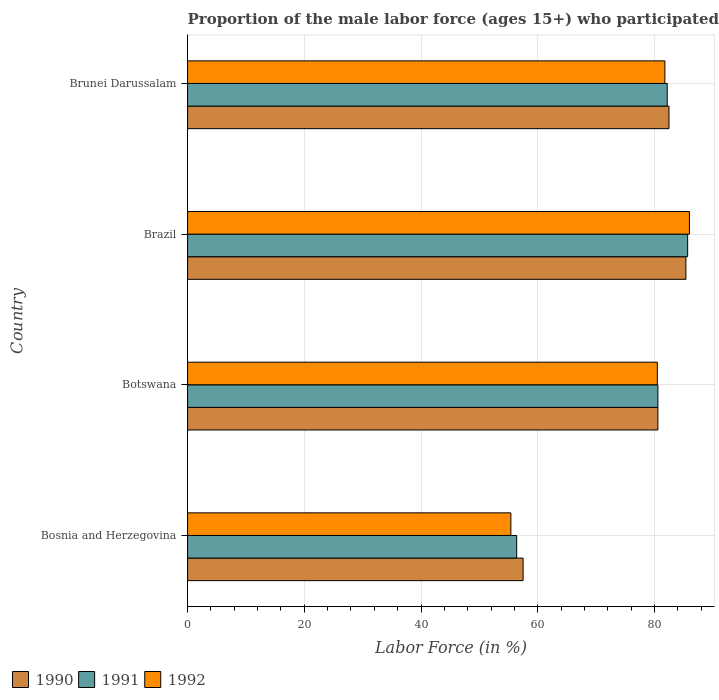How many different coloured bars are there?
Provide a short and direct response. 3. How many groups of bars are there?
Your response must be concise. 4. How many bars are there on the 3rd tick from the top?
Ensure brevity in your answer.  3. What is the label of the 1st group of bars from the top?
Keep it short and to the point. Brunei Darussalam. What is the proportion of the male labor force who participated in production in 1990 in Bosnia and Herzegovina?
Ensure brevity in your answer.  57.5. Across all countries, what is the maximum proportion of the male labor force who participated in production in 1991?
Provide a succinct answer. 85.7. Across all countries, what is the minimum proportion of the male labor force who participated in production in 1990?
Give a very brief answer. 57.5. In which country was the proportion of the male labor force who participated in production in 1992 maximum?
Your response must be concise. Brazil. In which country was the proportion of the male labor force who participated in production in 1992 minimum?
Give a very brief answer. Bosnia and Herzegovina. What is the total proportion of the male labor force who participated in production in 1991 in the graph?
Provide a short and direct response. 304.9. What is the difference between the proportion of the male labor force who participated in production in 1990 in Botswana and that in Brazil?
Ensure brevity in your answer.  -4.8. What is the difference between the proportion of the male labor force who participated in production in 1990 in Bosnia and Herzegovina and the proportion of the male labor force who participated in production in 1992 in Brunei Darussalam?
Your response must be concise. -24.3. What is the average proportion of the male labor force who participated in production in 1991 per country?
Your answer should be very brief. 76.22. What is the difference between the proportion of the male labor force who participated in production in 1991 and proportion of the male labor force who participated in production in 1990 in Brazil?
Keep it short and to the point. 0.3. What is the ratio of the proportion of the male labor force who participated in production in 1990 in Brazil to that in Brunei Darussalam?
Provide a succinct answer. 1.04. What is the difference between the highest and the second highest proportion of the male labor force who participated in production in 1990?
Your answer should be very brief. 2.9. What is the difference between the highest and the lowest proportion of the male labor force who participated in production in 1992?
Your answer should be compact. 30.6. What does the 1st bar from the top in Botswana represents?
Provide a short and direct response. 1992. What does the 3rd bar from the bottom in Brunei Darussalam represents?
Provide a succinct answer. 1992. How many bars are there?
Offer a terse response. 12. Are all the bars in the graph horizontal?
Your answer should be very brief. Yes. How are the legend labels stacked?
Offer a very short reply. Horizontal. What is the title of the graph?
Give a very brief answer. Proportion of the male labor force (ages 15+) who participated in production. What is the label or title of the X-axis?
Ensure brevity in your answer.  Labor Force (in %). What is the label or title of the Y-axis?
Keep it short and to the point. Country. What is the Labor Force (in %) of 1990 in Bosnia and Herzegovina?
Your answer should be compact. 57.5. What is the Labor Force (in %) of 1991 in Bosnia and Herzegovina?
Make the answer very short. 56.4. What is the Labor Force (in %) of 1992 in Bosnia and Herzegovina?
Your response must be concise. 55.4. What is the Labor Force (in %) in 1990 in Botswana?
Make the answer very short. 80.6. What is the Labor Force (in %) in 1991 in Botswana?
Your response must be concise. 80.6. What is the Labor Force (in %) of 1992 in Botswana?
Ensure brevity in your answer.  80.5. What is the Labor Force (in %) in 1990 in Brazil?
Give a very brief answer. 85.4. What is the Labor Force (in %) of 1991 in Brazil?
Your response must be concise. 85.7. What is the Labor Force (in %) in 1992 in Brazil?
Your response must be concise. 86. What is the Labor Force (in %) in 1990 in Brunei Darussalam?
Keep it short and to the point. 82.5. What is the Labor Force (in %) of 1991 in Brunei Darussalam?
Make the answer very short. 82.2. What is the Labor Force (in %) of 1992 in Brunei Darussalam?
Provide a succinct answer. 81.8. Across all countries, what is the maximum Labor Force (in %) in 1990?
Your response must be concise. 85.4. Across all countries, what is the maximum Labor Force (in %) of 1991?
Ensure brevity in your answer.  85.7. Across all countries, what is the maximum Labor Force (in %) in 1992?
Make the answer very short. 86. Across all countries, what is the minimum Labor Force (in %) in 1990?
Provide a succinct answer. 57.5. Across all countries, what is the minimum Labor Force (in %) in 1991?
Give a very brief answer. 56.4. Across all countries, what is the minimum Labor Force (in %) in 1992?
Your answer should be very brief. 55.4. What is the total Labor Force (in %) of 1990 in the graph?
Ensure brevity in your answer.  306. What is the total Labor Force (in %) in 1991 in the graph?
Make the answer very short. 304.9. What is the total Labor Force (in %) in 1992 in the graph?
Provide a succinct answer. 303.7. What is the difference between the Labor Force (in %) in 1990 in Bosnia and Herzegovina and that in Botswana?
Keep it short and to the point. -23.1. What is the difference between the Labor Force (in %) of 1991 in Bosnia and Herzegovina and that in Botswana?
Offer a terse response. -24.2. What is the difference between the Labor Force (in %) in 1992 in Bosnia and Herzegovina and that in Botswana?
Give a very brief answer. -25.1. What is the difference between the Labor Force (in %) in 1990 in Bosnia and Herzegovina and that in Brazil?
Give a very brief answer. -27.9. What is the difference between the Labor Force (in %) of 1991 in Bosnia and Herzegovina and that in Brazil?
Make the answer very short. -29.3. What is the difference between the Labor Force (in %) of 1992 in Bosnia and Herzegovina and that in Brazil?
Provide a short and direct response. -30.6. What is the difference between the Labor Force (in %) of 1991 in Bosnia and Herzegovina and that in Brunei Darussalam?
Provide a succinct answer. -25.8. What is the difference between the Labor Force (in %) of 1992 in Bosnia and Herzegovina and that in Brunei Darussalam?
Your answer should be very brief. -26.4. What is the difference between the Labor Force (in %) of 1991 in Botswana and that in Brazil?
Your response must be concise. -5.1. What is the difference between the Labor Force (in %) in 1992 in Botswana and that in Brazil?
Your response must be concise. -5.5. What is the difference between the Labor Force (in %) in 1991 in Botswana and that in Brunei Darussalam?
Offer a very short reply. -1.6. What is the difference between the Labor Force (in %) of 1990 in Bosnia and Herzegovina and the Labor Force (in %) of 1991 in Botswana?
Ensure brevity in your answer.  -23.1. What is the difference between the Labor Force (in %) in 1990 in Bosnia and Herzegovina and the Labor Force (in %) in 1992 in Botswana?
Offer a very short reply. -23. What is the difference between the Labor Force (in %) in 1991 in Bosnia and Herzegovina and the Labor Force (in %) in 1992 in Botswana?
Keep it short and to the point. -24.1. What is the difference between the Labor Force (in %) of 1990 in Bosnia and Herzegovina and the Labor Force (in %) of 1991 in Brazil?
Give a very brief answer. -28.2. What is the difference between the Labor Force (in %) in 1990 in Bosnia and Herzegovina and the Labor Force (in %) in 1992 in Brazil?
Your response must be concise. -28.5. What is the difference between the Labor Force (in %) in 1991 in Bosnia and Herzegovina and the Labor Force (in %) in 1992 in Brazil?
Your response must be concise. -29.6. What is the difference between the Labor Force (in %) in 1990 in Bosnia and Herzegovina and the Labor Force (in %) in 1991 in Brunei Darussalam?
Offer a terse response. -24.7. What is the difference between the Labor Force (in %) in 1990 in Bosnia and Herzegovina and the Labor Force (in %) in 1992 in Brunei Darussalam?
Give a very brief answer. -24.3. What is the difference between the Labor Force (in %) of 1991 in Bosnia and Herzegovina and the Labor Force (in %) of 1992 in Brunei Darussalam?
Give a very brief answer. -25.4. What is the difference between the Labor Force (in %) in 1990 in Botswana and the Labor Force (in %) in 1991 in Brazil?
Your answer should be very brief. -5.1. What is the difference between the Labor Force (in %) of 1990 in Botswana and the Labor Force (in %) of 1992 in Brazil?
Keep it short and to the point. -5.4. What is the difference between the Labor Force (in %) in 1991 in Botswana and the Labor Force (in %) in 1992 in Brazil?
Keep it short and to the point. -5.4. What is the difference between the Labor Force (in %) in 1990 in Botswana and the Labor Force (in %) in 1991 in Brunei Darussalam?
Your response must be concise. -1.6. What is the difference between the Labor Force (in %) in 1990 in Brazil and the Labor Force (in %) in 1992 in Brunei Darussalam?
Provide a succinct answer. 3.6. What is the average Labor Force (in %) of 1990 per country?
Your answer should be very brief. 76.5. What is the average Labor Force (in %) in 1991 per country?
Make the answer very short. 76.22. What is the average Labor Force (in %) of 1992 per country?
Your answer should be very brief. 75.92. What is the difference between the Labor Force (in %) of 1990 and Labor Force (in %) of 1991 in Bosnia and Herzegovina?
Your answer should be compact. 1.1. What is the difference between the Labor Force (in %) in 1990 and Labor Force (in %) in 1992 in Bosnia and Herzegovina?
Your answer should be very brief. 2.1. What is the difference between the Labor Force (in %) of 1991 and Labor Force (in %) of 1992 in Bosnia and Herzegovina?
Your response must be concise. 1. What is the difference between the Labor Force (in %) of 1990 and Labor Force (in %) of 1992 in Brazil?
Give a very brief answer. -0.6. What is the difference between the Labor Force (in %) in 1991 and Labor Force (in %) in 1992 in Brazil?
Your response must be concise. -0.3. What is the difference between the Labor Force (in %) of 1991 and Labor Force (in %) of 1992 in Brunei Darussalam?
Make the answer very short. 0.4. What is the ratio of the Labor Force (in %) of 1990 in Bosnia and Herzegovina to that in Botswana?
Your response must be concise. 0.71. What is the ratio of the Labor Force (in %) of 1991 in Bosnia and Herzegovina to that in Botswana?
Keep it short and to the point. 0.7. What is the ratio of the Labor Force (in %) in 1992 in Bosnia and Herzegovina to that in Botswana?
Provide a short and direct response. 0.69. What is the ratio of the Labor Force (in %) of 1990 in Bosnia and Herzegovina to that in Brazil?
Ensure brevity in your answer.  0.67. What is the ratio of the Labor Force (in %) in 1991 in Bosnia and Herzegovina to that in Brazil?
Make the answer very short. 0.66. What is the ratio of the Labor Force (in %) of 1992 in Bosnia and Herzegovina to that in Brazil?
Make the answer very short. 0.64. What is the ratio of the Labor Force (in %) of 1990 in Bosnia and Herzegovina to that in Brunei Darussalam?
Your response must be concise. 0.7. What is the ratio of the Labor Force (in %) of 1991 in Bosnia and Herzegovina to that in Brunei Darussalam?
Make the answer very short. 0.69. What is the ratio of the Labor Force (in %) of 1992 in Bosnia and Herzegovina to that in Brunei Darussalam?
Offer a terse response. 0.68. What is the ratio of the Labor Force (in %) of 1990 in Botswana to that in Brazil?
Provide a short and direct response. 0.94. What is the ratio of the Labor Force (in %) of 1991 in Botswana to that in Brazil?
Your response must be concise. 0.94. What is the ratio of the Labor Force (in %) of 1992 in Botswana to that in Brazil?
Make the answer very short. 0.94. What is the ratio of the Labor Force (in %) of 1990 in Botswana to that in Brunei Darussalam?
Your answer should be compact. 0.98. What is the ratio of the Labor Force (in %) of 1991 in Botswana to that in Brunei Darussalam?
Provide a succinct answer. 0.98. What is the ratio of the Labor Force (in %) of 1992 in Botswana to that in Brunei Darussalam?
Provide a short and direct response. 0.98. What is the ratio of the Labor Force (in %) of 1990 in Brazil to that in Brunei Darussalam?
Provide a succinct answer. 1.04. What is the ratio of the Labor Force (in %) in 1991 in Brazil to that in Brunei Darussalam?
Give a very brief answer. 1.04. What is the ratio of the Labor Force (in %) of 1992 in Brazil to that in Brunei Darussalam?
Offer a very short reply. 1.05. What is the difference between the highest and the second highest Labor Force (in %) in 1991?
Give a very brief answer. 3.5. What is the difference between the highest and the lowest Labor Force (in %) of 1990?
Offer a terse response. 27.9. What is the difference between the highest and the lowest Labor Force (in %) in 1991?
Your answer should be very brief. 29.3. What is the difference between the highest and the lowest Labor Force (in %) in 1992?
Offer a terse response. 30.6. 